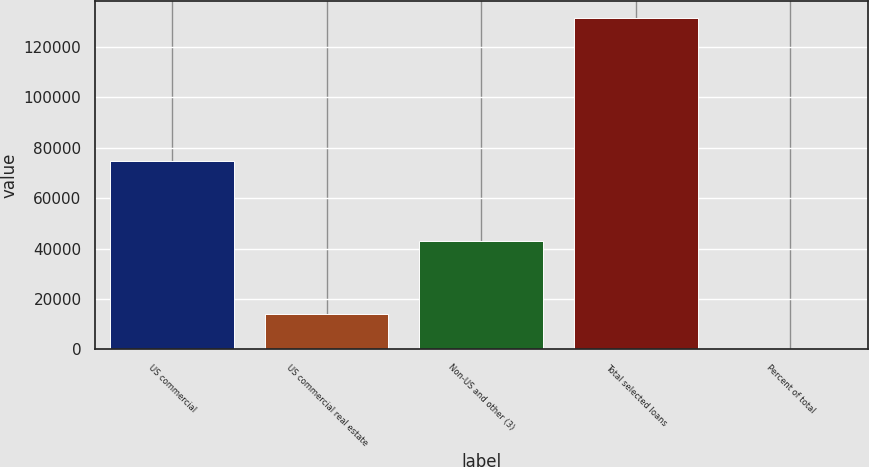Convert chart. <chart><loc_0><loc_0><loc_500><loc_500><bar_chart><fcel>US commercial<fcel>US commercial real estate<fcel>Non-US and other (3)<fcel>Total selected loans<fcel>Percent of total<nl><fcel>74563<fcel>14015<fcel>42933<fcel>131511<fcel>29<nl></chart> 